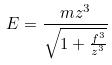<formula> <loc_0><loc_0><loc_500><loc_500>E = \frac { m z ^ { 3 } } { \sqrt { 1 + \frac { f ^ { 3 } } { z ^ { 3 } } } }</formula> 